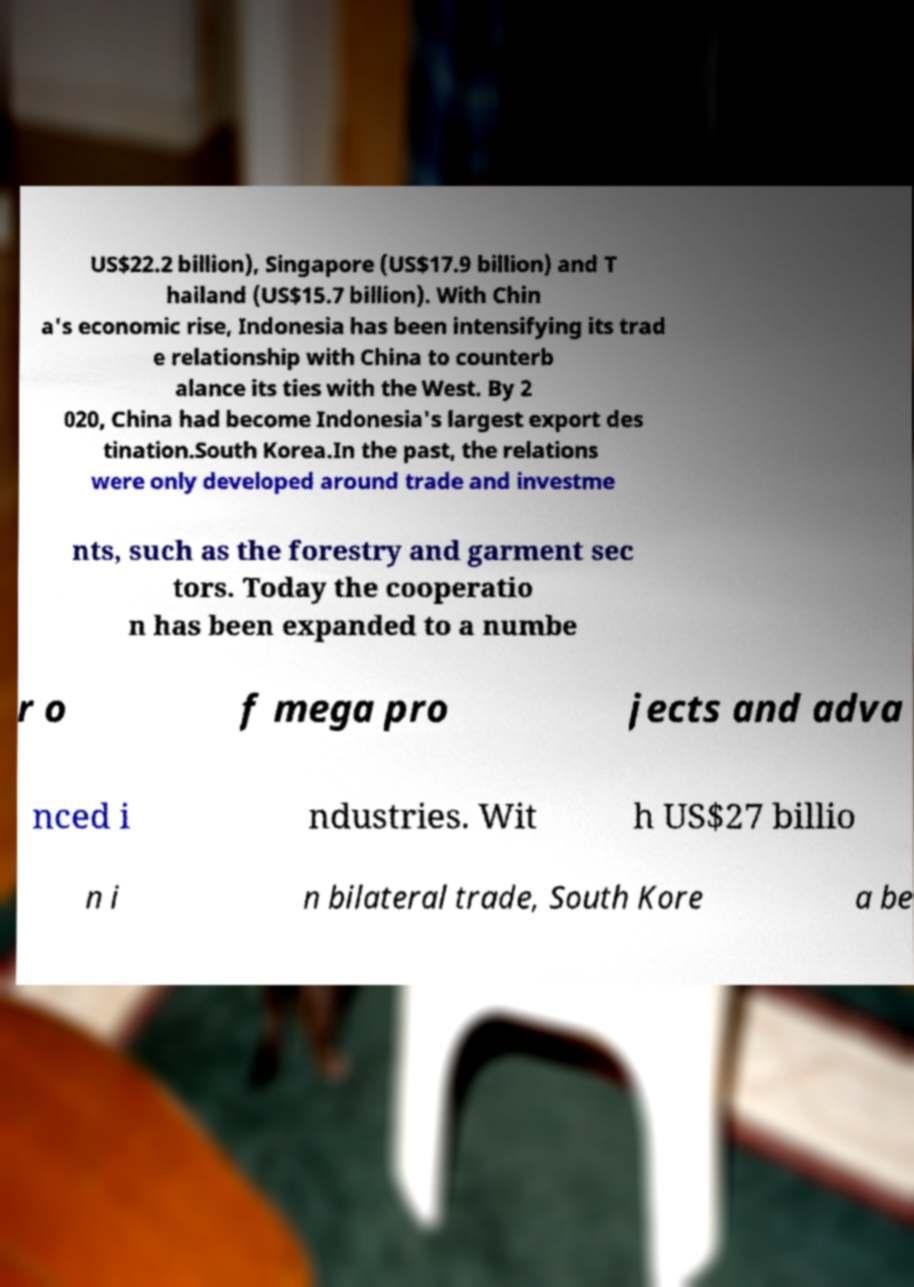Please identify and transcribe the text found in this image. US$22.2 billion), Singapore (US$17.9 billion) and T hailand (US$15.7 billion). With Chin a's economic rise, Indonesia has been intensifying its trad e relationship with China to counterb alance its ties with the West. By 2 020, China had become Indonesia's largest export des tination.South Korea.In the past, the relations were only developed around trade and investme nts, such as the forestry and garment sec tors. Today the cooperatio n has been expanded to a numbe r o f mega pro jects and adva nced i ndustries. Wit h US$27 billio n i n bilateral trade, South Kore a be 